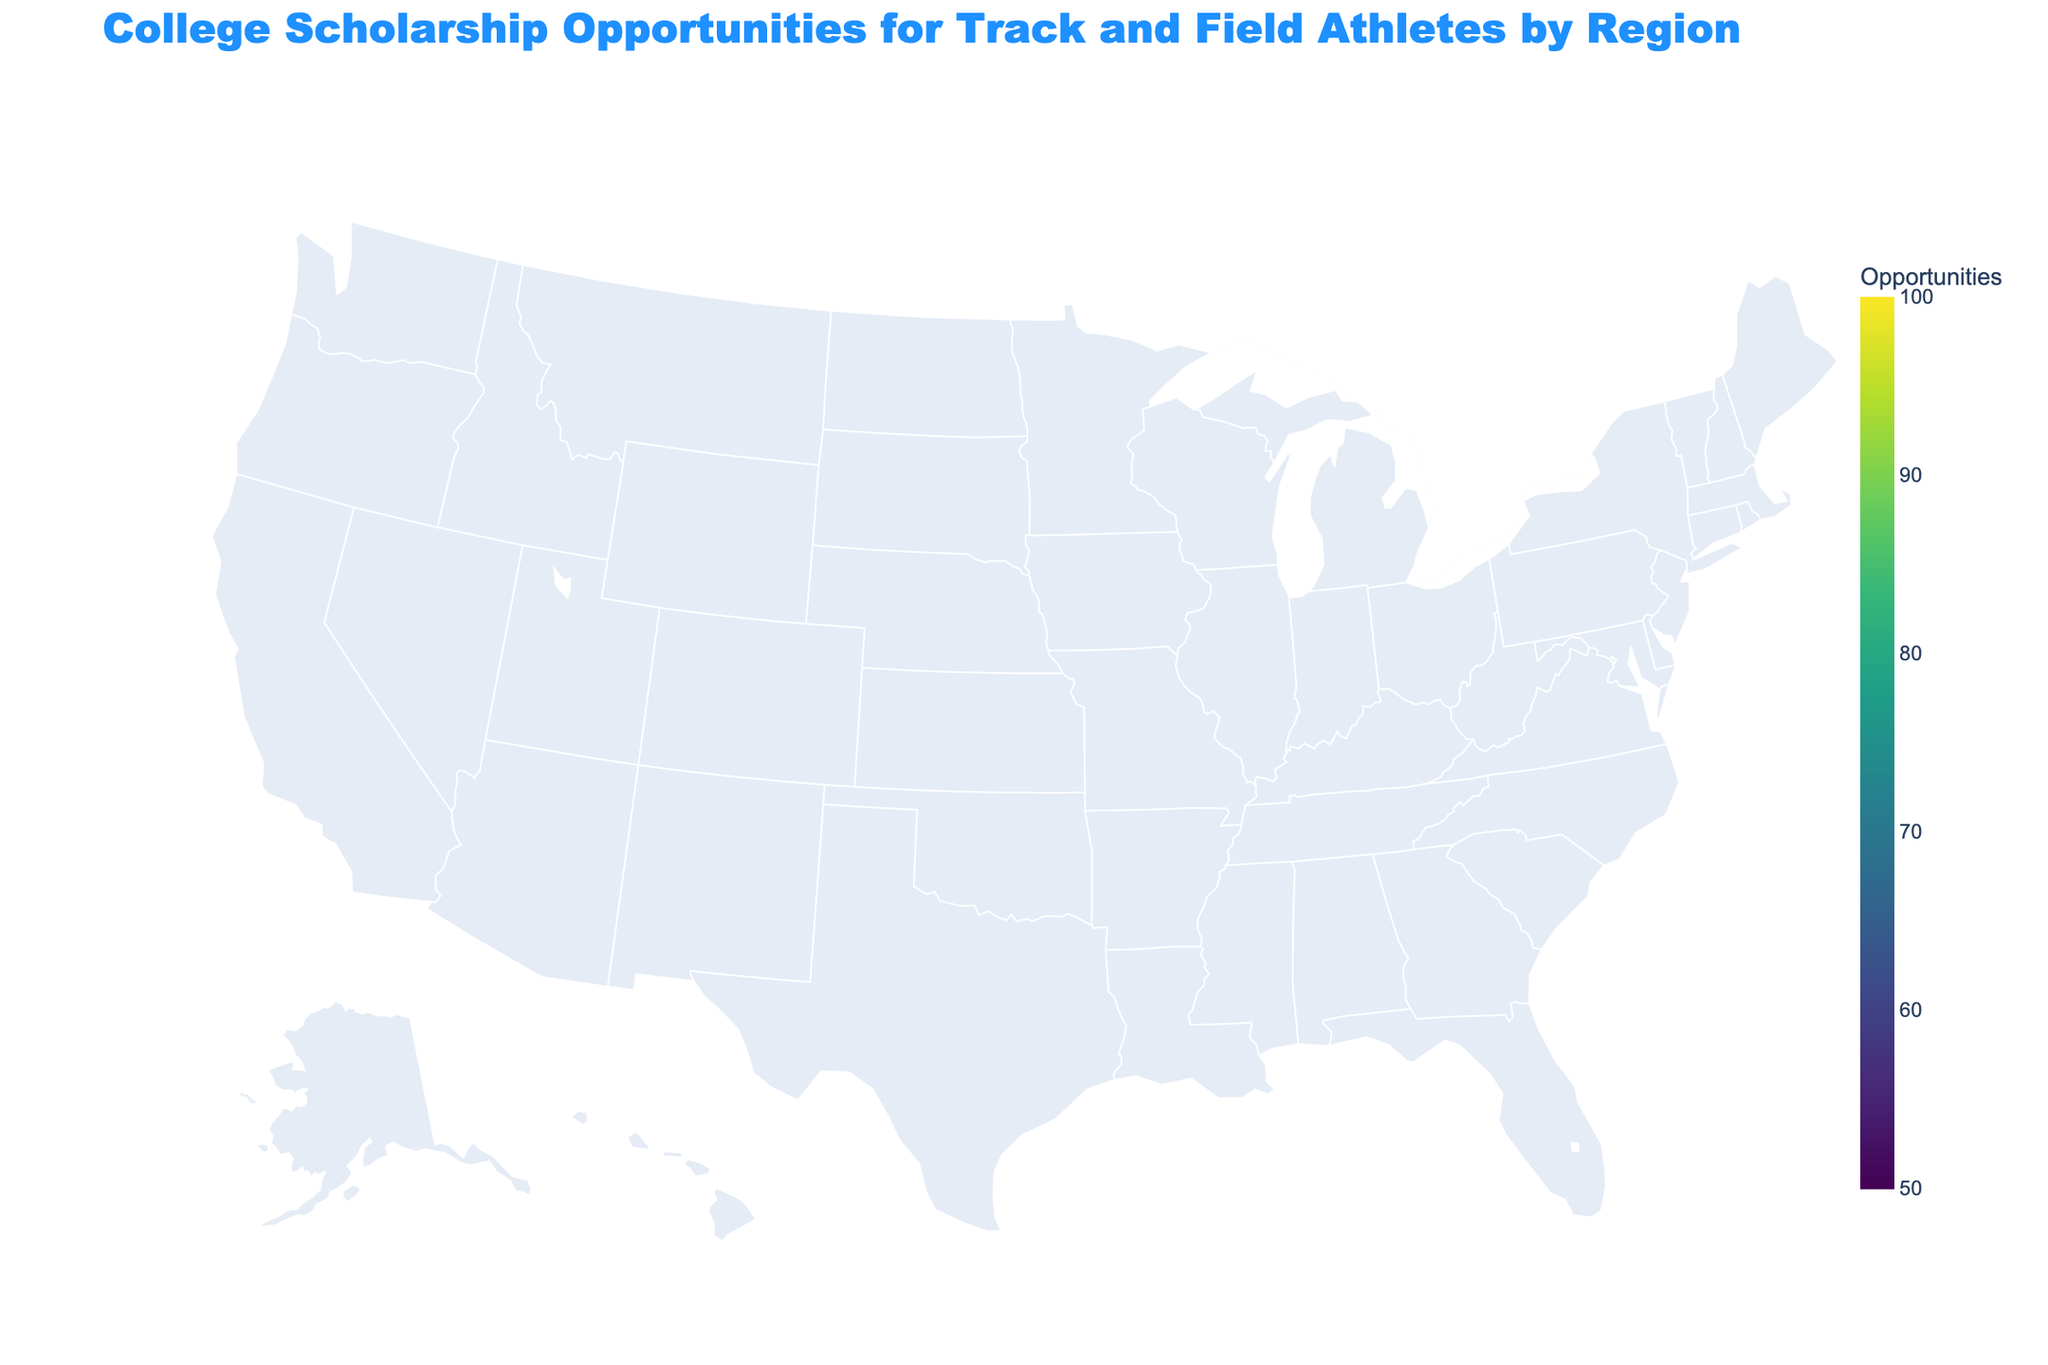How many regions have scholarship opportunities equal to or above 85? To find the regions with scholarship opportunities equal to or greater than 85, look at the color scale and regions colored in the highest colors near the top of the scale. They are Southeast, West Coast, South, Florida, California. There are 5 such regions.
Answer: 5 Which region has the lowest scholarship opportunities? Identify the region with the lightest color, as it represents the lowest value on the color scale. The Pacific Northwest has the lightest color with a value of 55.
Answer: Pacific Northwest Is the Midwest region among the top 3 regions in terms of scholarship opportunities? Check the values for each region and find the top 3 (California, Southeast, West Coast with 90, 90, and 85). The Midwest has a value of 80, which is not in the top 3.
Answer: No What is the average number of scholarship opportunities across all regions? To find this, sum up all the scholarship opportunities and divide by the number of regions. The sum of values is 1415 and there are 20 regions. Average = 1415 / 20 = 70.75
Answer: 70.75 Which regions have exactly the same scholarship opportunities? Look for regions with identical values. Illinois and Great Lakes both have 75, so do North Carolina and Texas with 80, and Southeast and California with 90.
Answer: Illinois and Great Lakes, North Carolina and Texas, Southeast and California Is New England above or below the average number of scholarship opportunities? The average number of opportunities is approximately 70.75. New England has 65, which is below this average.
Answer: Below What is the difference in scholarship opportunities between Florida and Ohio? Florida has 85 opportunities, and Ohio has 70. The difference is 85 - 70 = 15.
Answer: 15 Which region among Rocky Mountains and New England offers more scholarship opportunities? Compare the values of Rocky Mountains (60) and New England (65). New England has more.
Answer: New England How many regions offer more than 75 scholarship opportunities but less than 90? Identify regions with values between 75 and 90. They are Midwest (80), West Coast (85), Texas (80), South (85), Florida (85), North Carolina (80). There are 6 such regions.
Answer: 6 What is the median scholarship opportunity for the listed regions? List all values: 55, 60, 65, 65, 65, 70, 70, 70, 75, 75, 75, 80, 80, 80, 85, 85, 85, 90, 90. With an odd number of 19 values, the median is the 10th value. So, the median is 75.
Answer: 75 